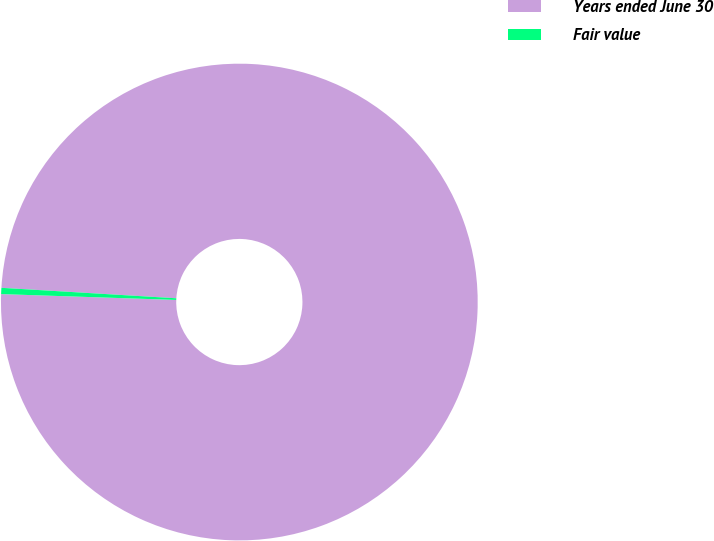Convert chart. <chart><loc_0><loc_0><loc_500><loc_500><pie_chart><fcel>Years ended June 30<fcel>Fair value<nl><fcel>99.58%<fcel>0.42%<nl></chart> 